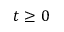Convert formula to latex. <formula><loc_0><loc_0><loc_500><loc_500>t \geq 0</formula> 